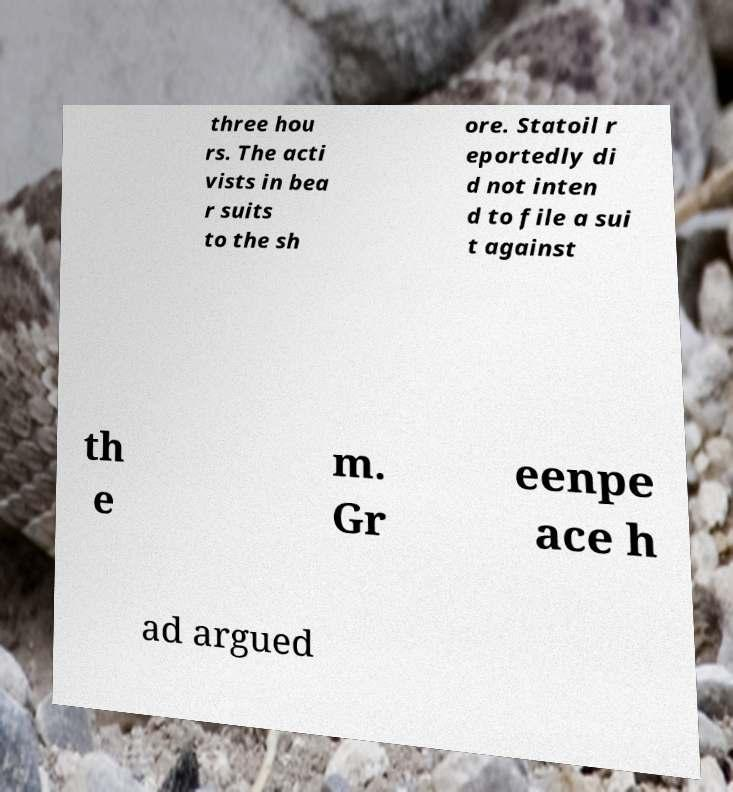Can you accurately transcribe the text from the provided image for me? three hou rs. The acti vists in bea r suits to the sh ore. Statoil r eportedly di d not inten d to file a sui t against th e m. Gr eenpe ace h ad argued 